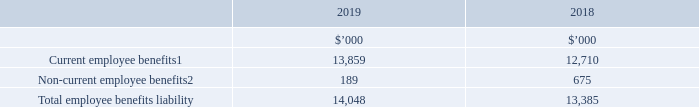Section D: People
This section provides information about our employee benefit obligations, including annual leave, long service leave and post-employment benefits. It also includes details about our share plans and the compensation paid to Key Management Personnel.
15. EMPLOYEE BENEFITS.
1. Included within current provisions in the statement of financial position.
2. Included within non-current provisions in the statement of financial position.
Employee benefits liability
Employee benefits liability represents amounts provided for annual leave and long service leave. The current portion for this provision includes the total amount accrued for annual leave entitlements and the amounts accrued for long service leave entitlements that have vested due to employees having completed the required period of service.
Based on past experience, the Group does not expect the full amount of annual leave or long service leave balances classified as current liabilities to be settled within the next 12 months. These amounts are presented as current liabilities since the Group does not have an unconditional right to defer the settlement of these amounts in the event employees wish to use their leave entitlement.
How much was the current employee benefits in 2019?
Answer scale should be: thousand. 13,859. What was the total employee benefits liability in 2018?
Answer scale should be: thousand. 13,385. What do employee benefits liability represent? Amounts provided for annual leave and long service leave. What was the percentage change in current employee benefits in 2018 and 2019?
Answer scale should be: percent. (13,859 - 12,710) / 12,710 
Answer: 9.04. What was the 2019 percentage change in total employee benefits liability?
Answer scale should be: percent. (14,048 - 13,385) / 13,385 
Answer: 4.95. What was the average non-current employee benefits for both years?
Answer scale should be: thousand. (189 + 675) / 2 
Answer: 432. 